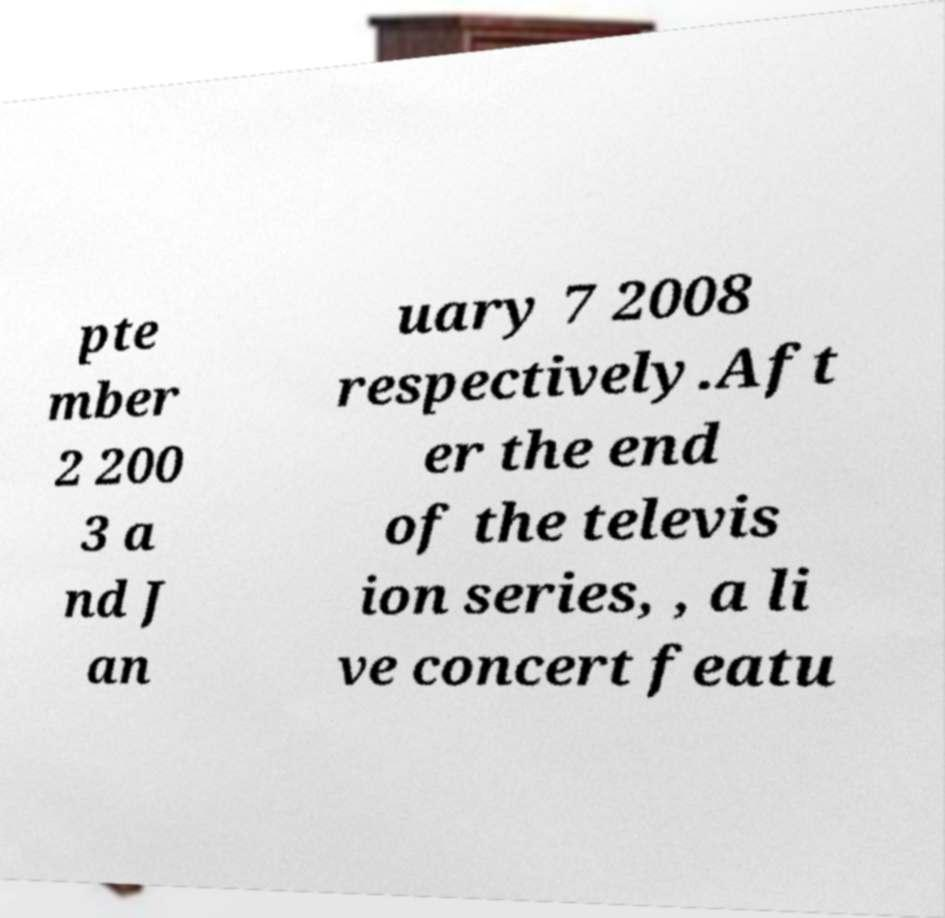For documentation purposes, I need the text within this image transcribed. Could you provide that? pte mber 2 200 3 a nd J an uary 7 2008 respectively.Aft er the end of the televis ion series, , a li ve concert featu 